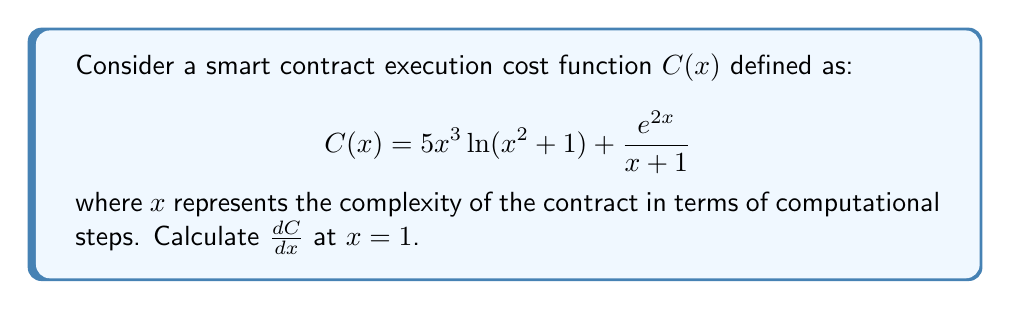Could you help me with this problem? To find the derivative of $C(x)$, we need to use the product rule, chain rule, and the derivative of the natural logarithm and exponential functions.

1. Let's break down $C(x)$ into two parts:
   $u(x) = 5x^3 \ln(x^2 + 1)$ and $v(x) = \frac{e^{2x}}{x + 1}$

2. For $u(x)$:
   Using the product rule, $\frac{d}{dx}[u(x)] = 5 \cdot 3x^2 \cdot \ln(x^2 + 1) + 5x^3 \cdot \frac{1}{x^2 + 1} \cdot 2x$
   $= 15x^2 \ln(x^2 + 1) + \frac{10x^4}{x^2 + 1}$

3. For $v(x)$:
   Using the quotient rule, $\frac{d}{dx}[v(x)] = \frac{(x+1) \cdot 2e^{2x} - e^{2x} \cdot 1}{(x+1)^2}$
   $= \frac{2(x+1)e^{2x} - e^{2x}}{(x+1)^2} = \frac{(2x+1)e^{2x}}{(x+1)^2}$

4. Combining the results:
   $\frac{dC}{dx} = 15x^2 \ln(x^2 + 1) + \frac{10x^4}{x^2 + 1} + \frac{(2x+1)e^{2x}}{(x+1)^2}$

5. Evaluating at $x = 1$:
   $\frac{dC}{dx}|_{x=1} = 15 \cdot 1^2 \cdot \ln(1^2 + 1) + \frac{10 \cdot 1^4}{1^2 + 1} + \frac{(2 \cdot 1 + 1)e^{2 \cdot 1}}{(1+1)^2}$
   $= 15 \ln(2) + \frac{10}{2} + \frac{3e^2}{4}$
   $= 15 \ln(2) + 5 + \frac{3e^2}{4}$
Answer: $\frac{dC}{dx}|_{x=1} = 15 \ln(2) + 5 + \frac{3e^2}{4} \approx 25.59$ 